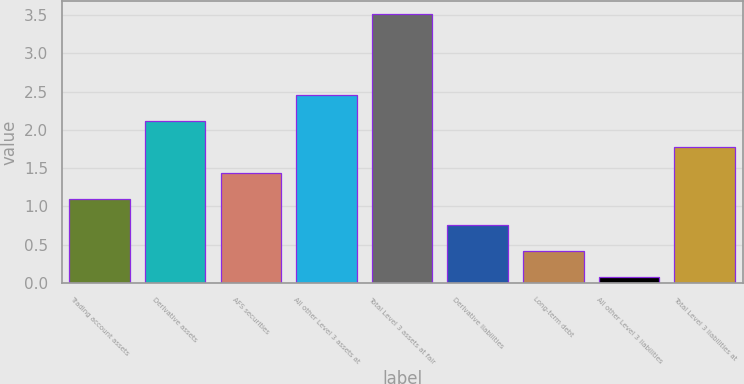Convert chart to OTSL. <chart><loc_0><loc_0><loc_500><loc_500><bar_chart><fcel>Trading account assets<fcel>Derivative assets<fcel>AFS securities<fcel>All other Level 3 assets at<fcel>Total Level 3 assets at fair<fcel>Derivative liabilities<fcel>Long-term debt<fcel>All other Level 3 liabilities<fcel>Total Level 3 liabilities at<nl><fcel>1.09<fcel>2.11<fcel>1.43<fcel>2.45<fcel>3.51<fcel>0.75<fcel>0.41<fcel>0.07<fcel>1.77<nl></chart> 